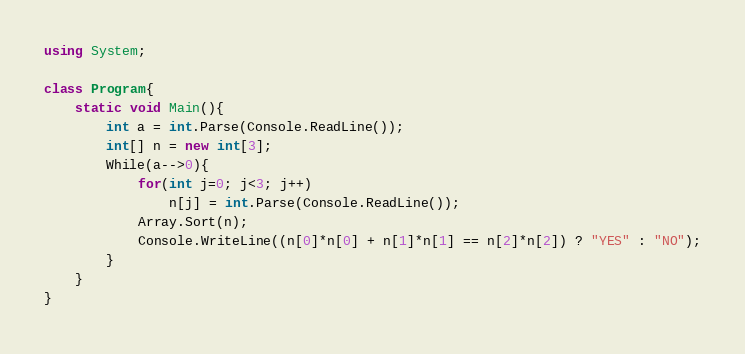<code> <loc_0><loc_0><loc_500><loc_500><_C#_>using System;

class Program{
	static void Main(){
		int a = int.Parse(Console.ReadLine());
		int[] n = new int[3];
		While(a-->0){
			for(int j=0; j<3; j++)
				n[j] = int.Parse(Console.ReadLine());
			Array.Sort(n);
			Console.WriteLine((n[0]*n[0] + n[1]*n[1] == n[2]*n[2]) ? "YES" : "NO");
		}
	}
}</code> 